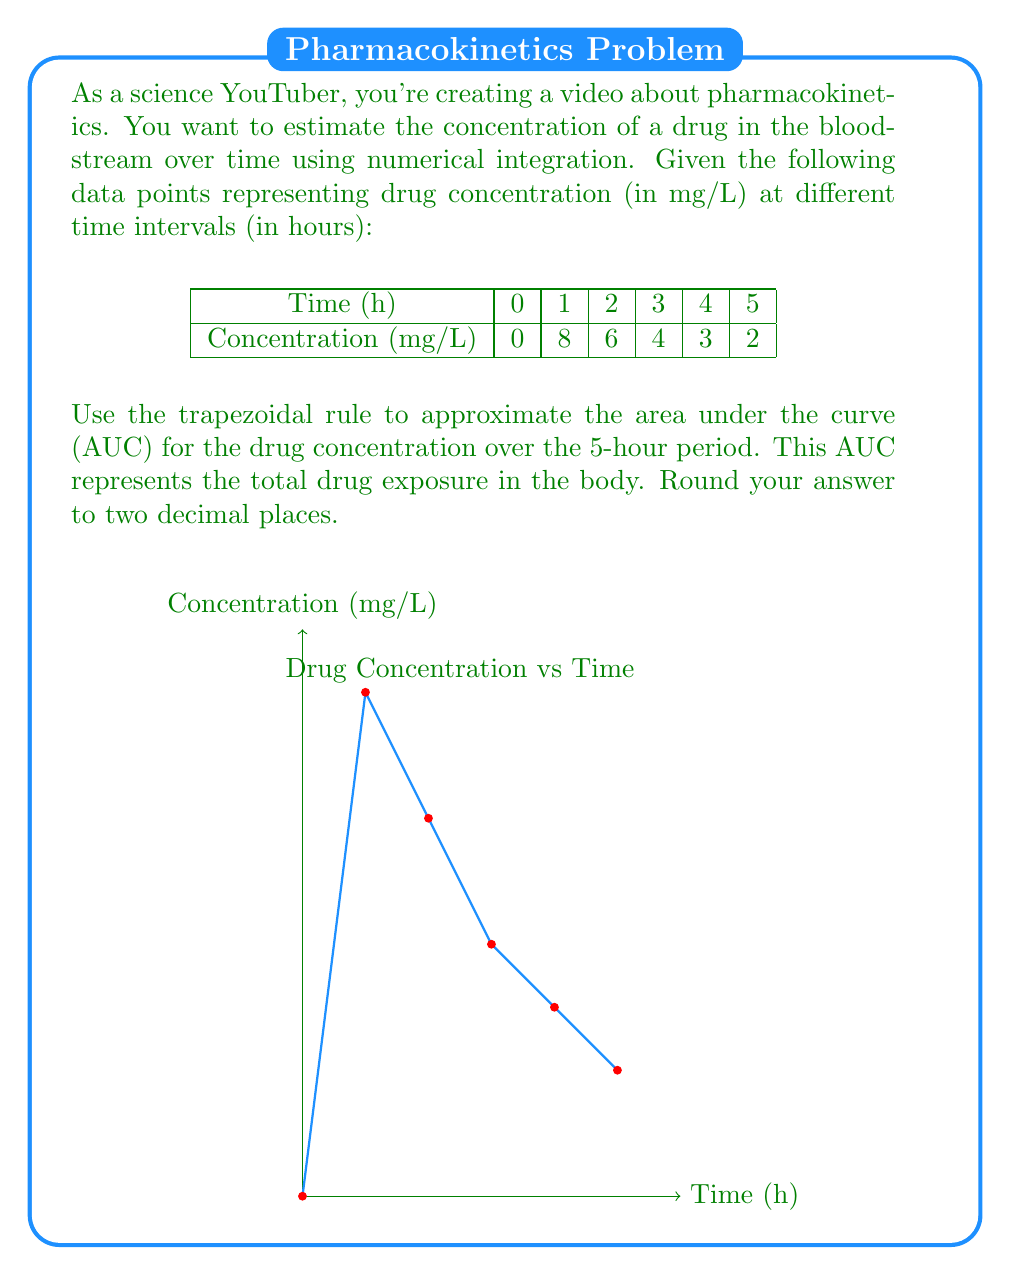Show me your answer to this math problem. To solve this problem, we'll use the trapezoidal rule for numerical integration. The trapezoidal rule approximates the area under a curve by dividing it into trapezoids and summing their areas.

The formula for the trapezoidal rule is:

$$AUC \approx \frac{1}{2}\sum_{i=1}^{n} (t_i - t_{i-1})(C_i + C_{i-1})$$

Where:
- $t_i$ is the time at point i
- $C_i$ is the concentration at point i
- n is the number of intervals

Let's calculate each trapezoid's area:

1. From 0 to 1 hour:
   $\frac{1}{2}(1-0)(0+8) = 4$ mg·h/L

2. From 1 to 2 hours:
   $\frac{1}{2}(2-1)(8+6) = 7$ mg·h/L

3. From 2 to 3 hours:
   $\frac{1}{2}(3-2)(6+4) = 5$ mg·h/L

4. From 3 to 4 hours:
   $\frac{1}{2}(4-3)(4+3) = 3.5$ mg·h/L

5. From 4 to 5 hours:
   $\frac{1}{2}(5-4)(3+2) = 2.5$ mg·h/L

Now, we sum all these areas:

$$AUC = 4 + 7 + 5 + 3.5 + 2.5 = 22 \text{ mg·h/L}$$

Rounding to two decimal places, we get 22.00 mg·h/L.
Answer: 22.00 mg·h/L 